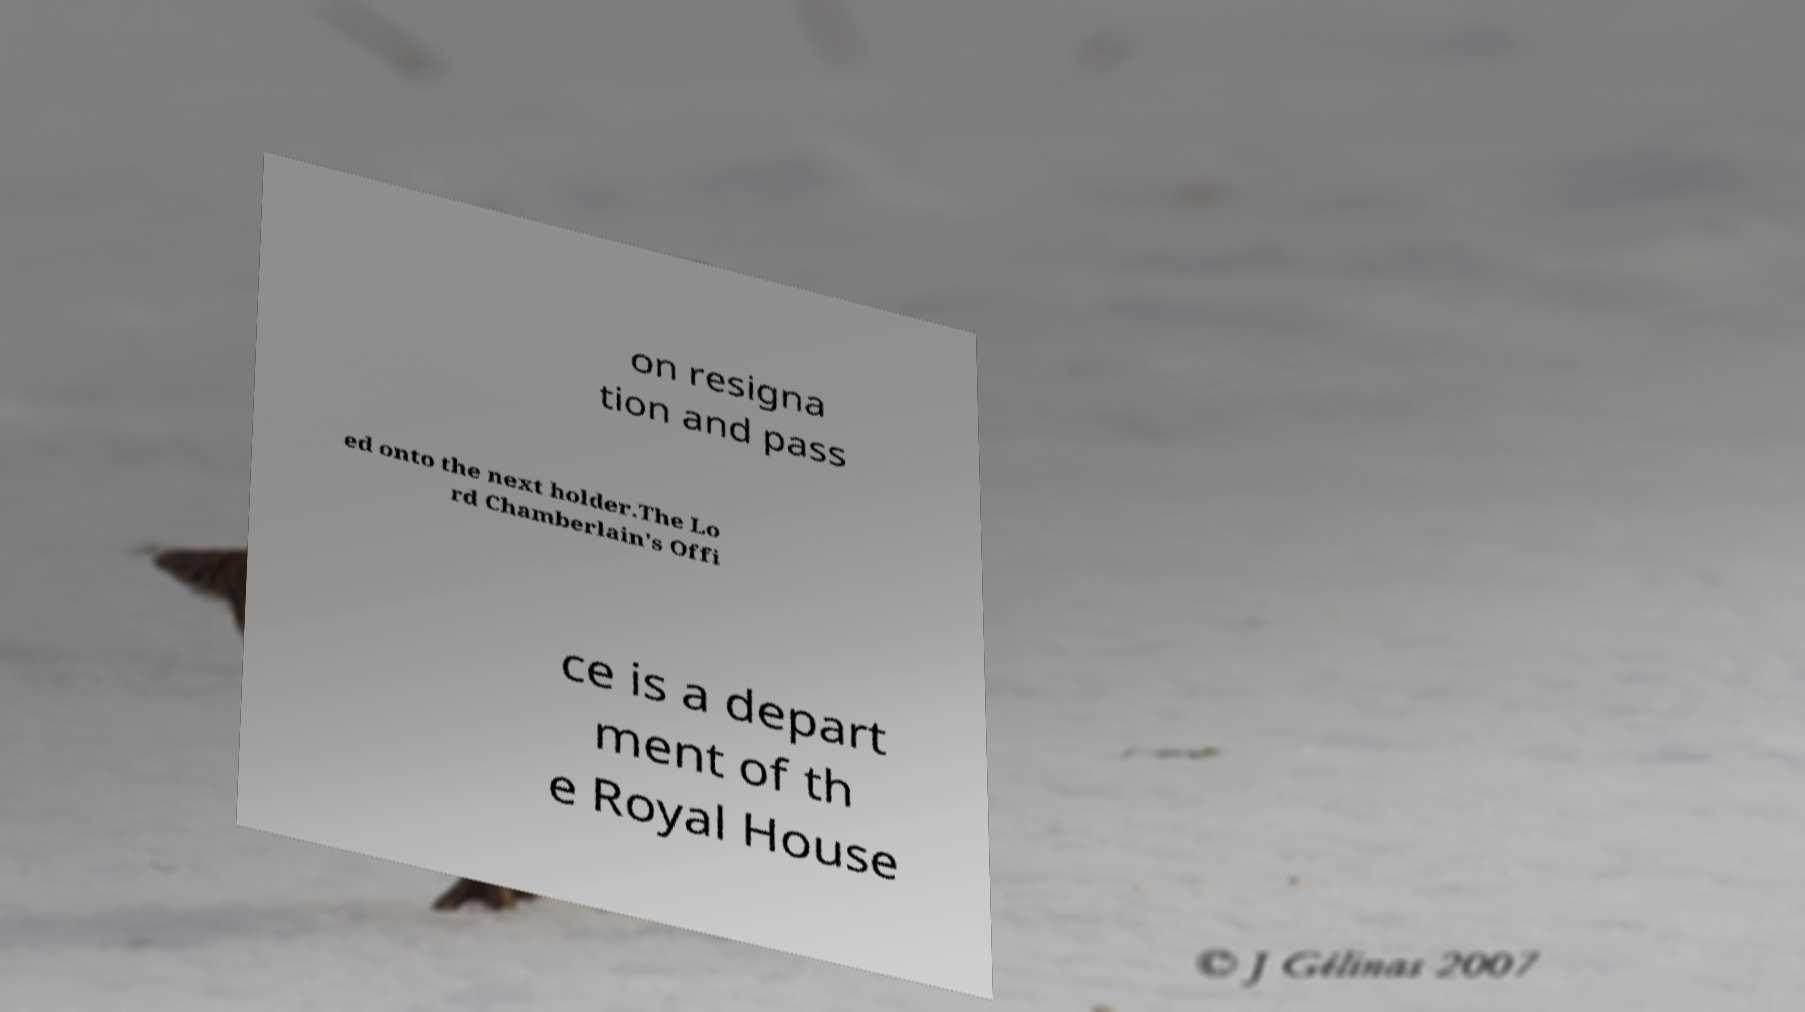Could you extract and type out the text from this image? on resigna tion and pass ed onto the next holder.The Lo rd Chamberlain's Offi ce is a depart ment of th e Royal House 